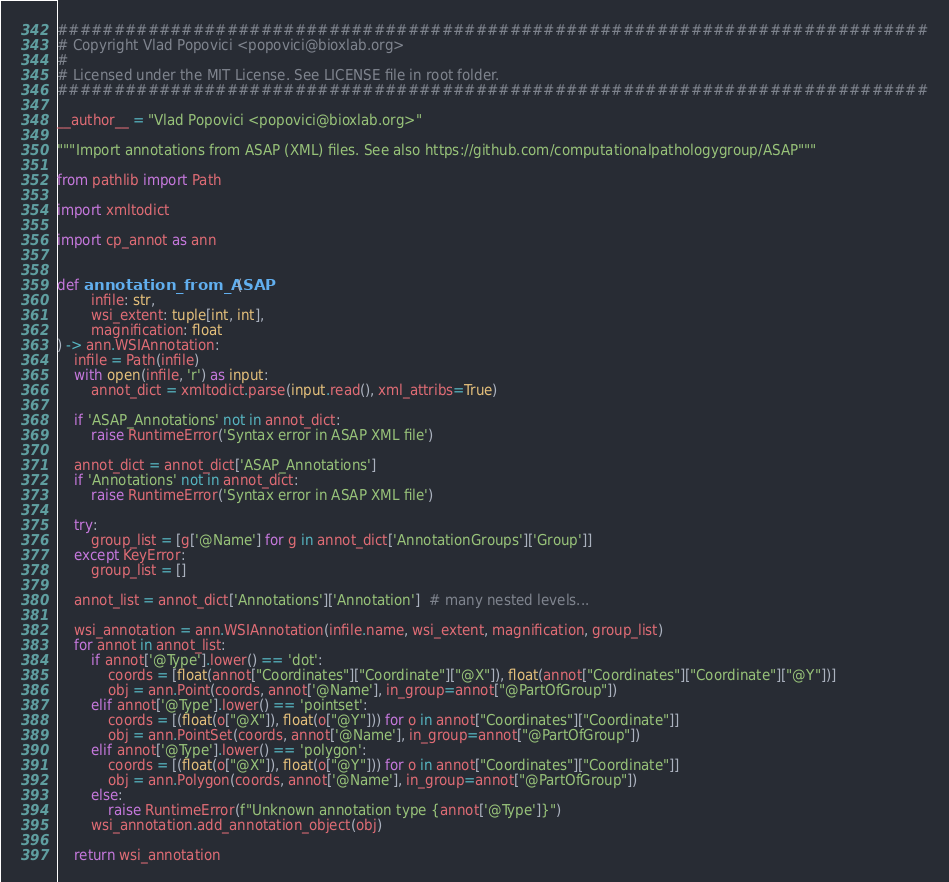<code> <loc_0><loc_0><loc_500><loc_500><_Python_>#############################################################################
# Copyright Vlad Popovici <popovici@bioxlab.org>
#
# Licensed under the MIT License. See LICENSE file in root folder.
#############################################################################

__author__ = "Vlad Popovici <popovici@bioxlab.org>"

"""Import annotations from ASAP (XML) files. See also https://github.com/computationalpathologygroup/ASAP"""

from pathlib import Path

import xmltodict

import cp_annot as ann


def annotation_from_ASAP(
        infile: str,
        wsi_extent: tuple[int, int],
        magnification: float
) -> ann.WSIAnnotation:
    infile = Path(infile)
    with open(infile, 'r') as input:
        annot_dict = xmltodict.parse(input.read(), xml_attribs=True)

    if 'ASAP_Annotations' not in annot_dict:
        raise RuntimeError('Syntax error in ASAP XML file')

    annot_dict = annot_dict['ASAP_Annotations']
    if 'Annotations' not in annot_dict:
        raise RuntimeError('Syntax error in ASAP XML file')

    try:
        group_list = [g['@Name'] for g in annot_dict['AnnotationGroups']['Group']]
    except KeyError:
        group_list = []

    annot_list = annot_dict['Annotations']['Annotation']  # many nested levels...

    wsi_annotation = ann.WSIAnnotation(infile.name, wsi_extent, magnification, group_list)
    for annot in annot_list:
        if annot['@Type'].lower() == 'dot':
            coords = [float(annot["Coordinates"]["Coordinate"]["@X"]), float(annot["Coordinates"]["Coordinate"]["@Y"])]
            obj = ann.Point(coords, annot['@Name'], in_group=annot["@PartOfGroup"])
        elif annot['@Type'].lower() == 'pointset':
            coords = [(float(o["@X"]), float(o["@Y"])) for o in annot["Coordinates"]["Coordinate"]]
            obj = ann.PointSet(coords, annot['@Name'], in_group=annot["@PartOfGroup"])
        elif annot['@Type'].lower() == 'polygon':
            coords = [(float(o["@X"]), float(o["@Y"])) for o in annot["Coordinates"]["Coordinate"]]
            obj = ann.Polygon(coords, annot['@Name'], in_group=annot["@PartOfGroup"])
        else:
            raise RuntimeError(f"Unknown annotation type {annot['@Type']}")
        wsi_annotation.add_annotation_object(obj)

    return wsi_annotation
</code> 